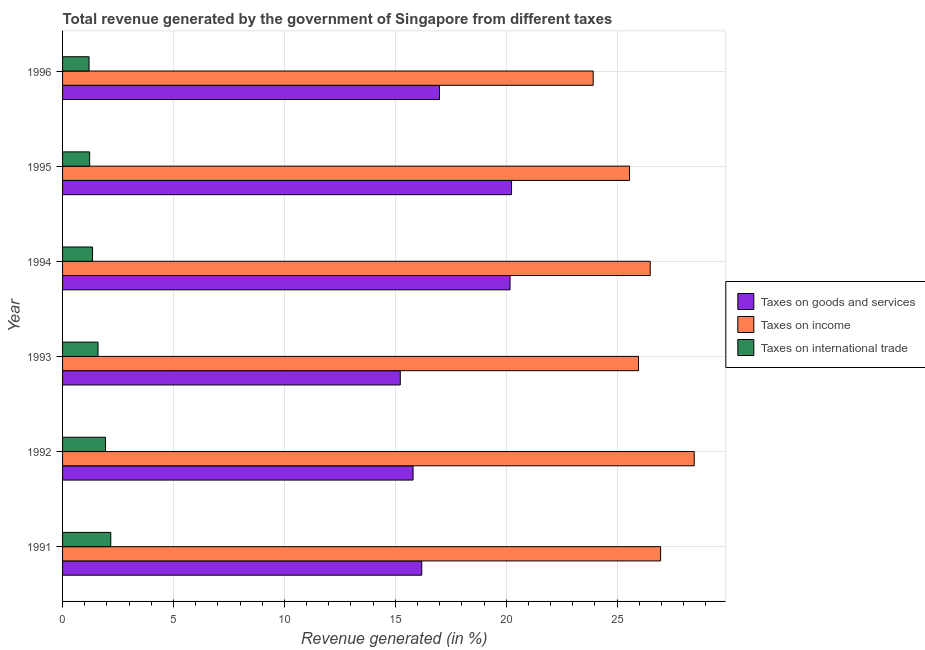How many groups of bars are there?
Offer a very short reply. 6. Are the number of bars per tick equal to the number of legend labels?
Offer a very short reply. Yes. Are the number of bars on each tick of the Y-axis equal?
Provide a succinct answer. Yes. How many bars are there on the 3rd tick from the bottom?
Your response must be concise. 3. What is the percentage of revenue generated by tax on international trade in 1996?
Give a very brief answer. 1.19. Across all years, what is the maximum percentage of revenue generated by taxes on income?
Give a very brief answer. 28.47. Across all years, what is the minimum percentage of revenue generated by taxes on goods and services?
Make the answer very short. 15.22. In which year was the percentage of revenue generated by taxes on goods and services maximum?
Make the answer very short. 1995. What is the total percentage of revenue generated by tax on international trade in the graph?
Your answer should be compact. 9.47. What is the difference between the percentage of revenue generated by taxes on income in 1992 and that in 1996?
Ensure brevity in your answer.  4.55. What is the difference between the percentage of revenue generated by taxes on income in 1994 and the percentage of revenue generated by tax on international trade in 1993?
Your response must be concise. 24.89. What is the average percentage of revenue generated by taxes on income per year?
Provide a succinct answer. 26.23. In the year 1993, what is the difference between the percentage of revenue generated by taxes on income and percentage of revenue generated by taxes on goods and services?
Offer a very short reply. 10.74. In how many years, is the percentage of revenue generated by tax on international trade greater than 4 %?
Your answer should be very brief. 0. What is the ratio of the percentage of revenue generated by taxes on income in 1992 to that in 1994?
Ensure brevity in your answer.  1.07. What is the difference between the highest and the second highest percentage of revenue generated by taxes on income?
Offer a very short reply. 1.51. What is the difference between the highest and the lowest percentage of revenue generated by taxes on income?
Offer a terse response. 4.55. Is the sum of the percentage of revenue generated by tax on international trade in 1993 and 1996 greater than the maximum percentage of revenue generated by taxes on income across all years?
Ensure brevity in your answer.  No. What does the 2nd bar from the top in 1991 represents?
Provide a short and direct response. Taxes on income. What does the 3rd bar from the bottom in 1993 represents?
Provide a short and direct response. Taxes on international trade. Are all the bars in the graph horizontal?
Offer a terse response. Yes. Does the graph contain any zero values?
Your response must be concise. No. How are the legend labels stacked?
Offer a very short reply. Vertical. What is the title of the graph?
Your response must be concise. Total revenue generated by the government of Singapore from different taxes. Does "Liquid fuel" appear as one of the legend labels in the graph?
Provide a succinct answer. No. What is the label or title of the X-axis?
Keep it short and to the point. Revenue generated (in %). What is the label or title of the Y-axis?
Your answer should be very brief. Year. What is the Revenue generated (in %) in Taxes on goods and services in 1991?
Keep it short and to the point. 16.19. What is the Revenue generated (in %) of Taxes on income in 1991?
Offer a very short reply. 26.96. What is the Revenue generated (in %) of Taxes on international trade in 1991?
Your answer should be compact. 2.17. What is the Revenue generated (in %) in Taxes on goods and services in 1992?
Your answer should be very brief. 15.8. What is the Revenue generated (in %) of Taxes on income in 1992?
Offer a terse response. 28.47. What is the Revenue generated (in %) in Taxes on international trade in 1992?
Your answer should be very brief. 1.93. What is the Revenue generated (in %) in Taxes on goods and services in 1993?
Offer a very short reply. 15.22. What is the Revenue generated (in %) of Taxes on income in 1993?
Your answer should be very brief. 25.96. What is the Revenue generated (in %) of Taxes on international trade in 1993?
Provide a short and direct response. 1.6. What is the Revenue generated (in %) of Taxes on goods and services in 1994?
Provide a short and direct response. 20.17. What is the Revenue generated (in %) in Taxes on income in 1994?
Ensure brevity in your answer.  26.49. What is the Revenue generated (in %) of Taxes on international trade in 1994?
Your response must be concise. 1.35. What is the Revenue generated (in %) in Taxes on goods and services in 1995?
Your answer should be compact. 20.24. What is the Revenue generated (in %) in Taxes on income in 1995?
Provide a succinct answer. 25.56. What is the Revenue generated (in %) in Taxes on international trade in 1995?
Your response must be concise. 1.22. What is the Revenue generated (in %) in Taxes on goods and services in 1996?
Ensure brevity in your answer.  16.99. What is the Revenue generated (in %) in Taxes on income in 1996?
Keep it short and to the point. 23.92. What is the Revenue generated (in %) in Taxes on international trade in 1996?
Give a very brief answer. 1.19. Across all years, what is the maximum Revenue generated (in %) of Taxes on goods and services?
Offer a terse response. 20.24. Across all years, what is the maximum Revenue generated (in %) of Taxes on income?
Give a very brief answer. 28.47. Across all years, what is the maximum Revenue generated (in %) of Taxes on international trade?
Offer a terse response. 2.17. Across all years, what is the minimum Revenue generated (in %) in Taxes on goods and services?
Your response must be concise. 15.22. Across all years, what is the minimum Revenue generated (in %) of Taxes on income?
Make the answer very short. 23.92. Across all years, what is the minimum Revenue generated (in %) in Taxes on international trade?
Ensure brevity in your answer.  1.19. What is the total Revenue generated (in %) in Taxes on goods and services in the graph?
Give a very brief answer. 104.62. What is the total Revenue generated (in %) of Taxes on income in the graph?
Your answer should be compact. 157.36. What is the total Revenue generated (in %) of Taxes on international trade in the graph?
Keep it short and to the point. 9.47. What is the difference between the Revenue generated (in %) in Taxes on goods and services in 1991 and that in 1992?
Give a very brief answer. 0.39. What is the difference between the Revenue generated (in %) in Taxes on income in 1991 and that in 1992?
Offer a terse response. -1.51. What is the difference between the Revenue generated (in %) in Taxes on international trade in 1991 and that in 1992?
Offer a very short reply. 0.24. What is the difference between the Revenue generated (in %) in Taxes on goods and services in 1991 and that in 1993?
Ensure brevity in your answer.  0.97. What is the difference between the Revenue generated (in %) of Taxes on income in 1991 and that in 1993?
Provide a short and direct response. 1. What is the difference between the Revenue generated (in %) of Taxes on international trade in 1991 and that in 1993?
Your answer should be very brief. 0.58. What is the difference between the Revenue generated (in %) of Taxes on goods and services in 1991 and that in 1994?
Your answer should be very brief. -3.98. What is the difference between the Revenue generated (in %) in Taxes on income in 1991 and that in 1994?
Offer a very short reply. 0.47. What is the difference between the Revenue generated (in %) of Taxes on international trade in 1991 and that in 1994?
Offer a terse response. 0.82. What is the difference between the Revenue generated (in %) in Taxes on goods and services in 1991 and that in 1995?
Make the answer very short. -4.05. What is the difference between the Revenue generated (in %) of Taxes on income in 1991 and that in 1995?
Give a very brief answer. 1.4. What is the difference between the Revenue generated (in %) in Taxes on international trade in 1991 and that in 1995?
Provide a short and direct response. 0.95. What is the difference between the Revenue generated (in %) of Taxes on goods and services in 1991 and that in 1996?
Your answer should be very brief. -0.8. What is the difference between the Revenue generated (in %) in Taxes on income in 1991 and that in 1996?
Your answer should be compact. 3.04. What is the difference between the Revenue generated (in %) in Taxes on international trade in 1991 and that in 1996?
Your answer should be compact. 0.98. What is the difference between the Revenue generated (in %) in Taxes on goods and services in 1992 and that in 1993?
Ensure brevity in your answer.  0.58. What is the difference between the Revenue generated (in %) of Taxes on income in 1992 and that in 1993?
Give a very brief answer. 2.51. What is the difference between the Revenue generated (in %) of Taxes on international trade in 1992 and that in 1993?
Provide a short and direct response. 0.34. What is the difference between the Revenue generated (in %) of Taxes on goods and services in 1992 and that in 1994?
Offer a very short reply. -4.37. What is the difference between the Revenue generated (in %) in Taxes on income in 1992 and that in 1994?
Offer a very short reply. 1.98. What is the difference between the Revenue generated (in %) in Taxes on international trade in 1992 and that in 1994?
Your answer should be compact. 0.58. What is the difference between the Revenue generated (in %) in Taxes on goods and services in 1992 and that in 1995?
Offer a very short reply. -4.44. What is the difference between the Revenue generated (in %) of Taxes on income in 1992 and that in 1995?
Your answer should be very brief. 2.92. What is the difference between the Revenue generated (in %) in Taxes on international trade in 1992 and that in 1995?
Provide a succinct answer. 0.71. What is the difference between the Revenue generated (in %) in Taxes on goods and services in 1992 and that in 1996?
Give a very brief answer. -1.19. What is the difference between the Revenue generated (in %) in Taxes on income in 1992 and that in 1996?
Your answer should be very brief. 4.55. What is the difference between the Revenue generated (in %) of Taxes on international trade in 1992 and that in 1996?
Your response must be concise. 0.74. What is the difference between the Revenue generated (in %) in Taxes on goods and services in 1993 and that in 1994?
Your response must be concise. -4.95. What is the difference between the Revenue generated (in %) of Taxes on income in 1993 and that in 1994?
Provide a succinct answer. -0.53. What is the difference between the Revenue generated (in %) in Taxes on international trade in 1993 and that in 1994?
Offer a very short reply. 0.25. What is the difference between the Revenue generated (in %) of Taxes on goods and services in 1993 and that in 1995?
Make the answer very short. -5.02. What is the difference between the Revenue generated (in %) in Taxes on income in 1993 and that in 1995?
Your answer should be compact. 0.4. What is the difference between the Revenue generated (in %) in Taxes on international trade in 1993 and that in 1995?
Keep it short and to the point. 0.38. What is the difference between the Revenue generated (in %) in Taxes on goods and services in 1993 and that in 1996?
Your answer should be compact. -1.77. What is the difference between the Revenue generated (in %) in Taxes on income in 1993 and that in 1996?
Provide a short and direct response. 2.04. What is the difference between the Revenue generated (in %) in Taxes on international trade in 1993 and that in 1996?
Offer a terse response. 0.4. What is the difference between the Revenue generated (in %) in Taxes on goods and services in 1994 and that in 1995?
Give a very brief answer. -0.07. What is the difference between the Revenue generated (in %) of Taxes on income in 1994 and that in 1995?
Ensure brevity in your answer.  0.93. What is the difference between the Revenue generated (in %) in Taxes on international trade in 1994 and that in 1995?
Your response must be concise. 0.13. What is the difference between the Revenue generated (in %) in Taxes on goods and services in 1994 and that in 1996?
Ensure brevity in your answer.  3.18. What is the difference between the Revenue generated (in %) of Taxes on income in 1994 and that in 1996?
Keep it short and to the point. 2.57. What is the difference between the Revenue generated (in %) in Taxes on international trade in 1994 and that in 1996?
Provide a short and direct response. 0.16. What is the difference between the Revenue generated (in %) in Taxes on goods and services in 1995 and that in 1996?
Provide a short and direct response. 3.25. What is the difference between the Revenue generated (in %) of Taxes on income in 1995 and that in 1996?
Keep it short and to the point. 1.64. What is the difference between the Revenue generated (in %) in Taxes on international trade in 1995 and that in 1996?
Your response must be concise. 0.03. What is the difference between the Revenue generated (in %) in Taxes on goods and services in 1991 and the Revenue generated (in %) in Taxes on income in 1992?
Offer a terse response. -12.28. What is the difference between the Revenue generated (in %) of Taxes on goods and services in 1991 and the Revenue generated (in %) of Taxes on international trade in 1992?
Keep it short and to the point. 14.26. What is the difference between the Revenue generated (in %) of Taxes on income in 1991 and the Revenue generated (in %) of Taxes on international trade in 1992?
Give a very brief answer. 25.02. What is the difference between the Revenue generated (in %) in Taxes on goods and services in 1991 and the Revenue generated (in %) in Taxes on income in 1993?
Make the answer very short. -9.77. What is the difference between the Revenue generated (in %) in Taxes on goods and services in 1991 and the Revenue generated (in %) in Taxes on international trade in 1993?
Give a very brief answer. 14.59. What is the difference between the Revenue generated (in %) in Taxes on income in 1991 and the Revenue generated (in %) in Taxes on international trade in 1993?
Offer a terse response. 25.36. What is the difference between the Revenue generated (in %) of Taxes on goods and services in 1991 and the Revenue generated (in %) of Taxes on income in 1994?
Make the answer very short. -10.3. What is the difference between the Revenue generated (in %) in Taxes on goods and services in 1991 and the Revenue generated (in %) in Taxes on international trade in 1994?
Your answer should be compact. 14.84. What is the difference between the Revenue generated (in %) of Taxes on income in 1991 and the Revenue generated (in %) of Taxes on international trade in 1994?
Provide a succinct answer. 25.61. What is the difference between the Revenue generated (in %) of Taxes on goods and services in 1991 and the Revenue generated (in %) of Taxes on income in 1995?
Ensure brevity in your answer.  -9.37. What is the difference between the Revenue generated (in %) in Taxes on goods and services in 1991 and the Revenue generated (in %) in Taxes on international trade in 1995?
Your answer should be very brief. 14.97. What is the difference between the Revenue generated (in %) of Taxes on income in 1991 and the Revenue generated (in %) of Taxes on international trade in 1995?
Your response must be concise. 25.74. What is the difference between the Revenue generated (in %) in Taxes on goods and services in 1991 and the Revenue generated (in %) in Taxes on income in 1996?
Offer a very short reply. -7.73. What is the difference between the Revenue generated (in %) of Taxes on goods and services in 1991 and the Revenue generated (in %) of Taxes on international trade in 1996?
Your answer should be compact. 15. What is the difference between the Revenue generated (in %) in Taxes on income in 1991 and the Revenue generated (in %) in Taxes on international trade in 1996?
Provide a short and direct response. 25.77. What is the difference between the Revenue generated (in %) of Taxes on goods and services in 1992 and the Revenue generated (in %) of Taxes on income in 1993?
Offer a terse response. -10.16. What is the difference between the Revenue generated (in %) in Taxes on goods and services in 1992 and the Revenue generated (in %) in Taxes on international trade in 1993?
Your answer should be very brief. 14.2. What is the difference between the Revenue generated (in %) in Taxes on income in 1992 and the Revenue generated (in %) in Taxes on international trade in 1993?
Keep it short and to the point. 26.88. What is the difference between the Revenue generated (in %) in Taxes on goods and services in 1992 and the Revenue generated (in %) in Taxes on income in 1994?
Your answer should be very brief. -10.69. What is the difference between the Revenue generated (in %) of Taxes on goods and services in 1992 and the Revenue generated (in %) of Taxes on international trade in 1994?
Your answer should be very brief. 14.45. What is the difference between the Revenue generated (in %) of Taxes on income in 1992 and the Revenue generated (in %) of Taxes on international trade in 1994?
Provide a succinct answer. 27.12. What is the difference between the Revenue generated (in %) in Taxes on goods and services in 1992 and the Revenue generated (in %) in Taxes on income in 1995?
Offer a very short reply. -9.76. What is the difference between the Revenue generated (in %) in Taxes on goods and services in 1992 and the Revenue generated (in %) in Taxes on international trade in 1995?
Keep it short and to the point. 14.58. What is the difference between the Revenue generated (in %) of Taxes on income in 1992 and the Revenue generated (in %) of Taxes on international trade in 1995?
Your answer should be compact. 27.25. What is the difference between the Revenue generated (in %) of Taxes on goods and services in 1992 and the Revenue generated (in %) of Taxes on income in 1996?
Your answer should be compact. -8.12. What is the difference between the Revenue generated (in %) of Taxes on goods and services in 1992 and the Revenue generated (in %) of Taxes on international trade in 1996?
Provide a short and direct response. 14.61. What is the difference between the Revenue generated (in %) of Taxes on income in 1992 and the Revenue generated (in %) of Taxes on international trade in 1996?
Make the answer very short. 27.28. What is the difference between the Revenue generated (in %) in Taxes on goods and services in 1993 and the Revenue generated (in %) in Taxes on income in 1994?
Give a very brief answer. -11.27. What is the difference between the Revenue generated (in %) in Taxes on goods and services in 1993 and the Revenue generated (in %) in Taxes on international trade in 1994?
Offer a very short reply. 13.87. What is the difference between the Revenue generated (in %) in Taxes on income in 1993 and the Revenue generated (in %) in Taxes on international trade in 1994?
Your answer should be very brief. 24.61. What is the difference between the Revenue generated (in %) of Taxes on goods and services in 1993 and the Revenue generated (in %) of Taxes on income in 1995?
Ensure brevity in your answer.  -10.33. What is the difference between the Revenue generated (in %) in Taxes on goods and services in 1993 and the Revenue generated (in %) in Taxes on international trade in 1995?
Give a very brief answer. 14. What is the difference between the Revenue generated (in %) of Taxes on income in 1993 and the Revenue generated (in %) of Taxes on international trade in 1995?
Keep it short and to the point. 24.74. What is the difference between the Revenue generated (in %) of Taxes on goods and services in 1993 and the Revenue generated (in %) of Taxes on income in 1996?
Your answer should be compact. -8.7. What is the difference between the Revenue generated (in %) in Taxes on goods and services in 1993 and the Revenue generated (in %) in Taxes on international trade in 1996?
Make the answer very short. 14.03. What is the difference between the Revenue generated (in %) in Taxes on income in 1993 and the Revenue generated (in %) in Taxes on international trade in 1996?
Offer a very short reply. 24.77. What is the difference between the Revenue generated (in %) in Taxes on goods and services in 1994 and the Revenue generated (in %) in Taxes on income in 1995?
Offer a very short reply. -5.39. What is the difference between the Revenue generated (in %) in Taxes on goods and services in 1994 and the Revenue generated (in %) in Taxes on international trade in 1995?
Ensure brevity in your answer.  18.95. What is the difference between the Revenue generated (in %) in Taxes on income in 1994 and the Revenue generated (in %) in Taxes on international trade in 1995?
Ensure brevity in your answer.  25.27. What is the difference between the Revenue generated (in %) in Taxes on goods and services in 1994 and the Revenue generated (in %) in Taxes on income in 1996?
Ensure brevity in your answer.  -3.75. What is the difference between the Revenue generated (in %) in Taxes on goods and services in 1994 and the Revenue generated (in %) in Taxes on international trade in 1996?
Ensure brevity in your answer.  18.98. What is the difference between the Revenue generated (in %) in Taxes on income in 1994 and the Revenue generated (in %) in Taxes on international trade in 1996?
Your answer should be compact. 25.3. What is the difference between the Revenue generated (in %) of Taxes on goods and services in 1995 and the Revenue generated (in %) of Taxes on income in 1996?
Your response must be concise. -3.68. What is the difference between the Revenue generated (in %) of Taxes on goods and services in 1995 and the Revenue generated (in %) of Taxes on international trade in 1996?
Offer a terse response. 19.05. What is the difference between the Revenue generated (in %) in Taxes on income in 1995 and the Revenue generated (in %) in Taxes on international trade in 1996?
Your answer should be compact. 24.36. What is the average Revenue generated (in %) of Taxes on goods and services per year?
Keep it short and to the point. 17.44. What is the average Revenue generated (in %) of Taxes on income per year?
Keep it short and to the point. 26.23. What is the average Revenue generated (in %) of Taxes on international trade per year?
Provide a succinct answer. 1.58. In the year 1991, what is the difference between the Revenue generated (in %) of Taxes on goods and services and Revenue generated (in %) of Taxes on income?
Ensure brevity in your answer.  -10.77. In the year 1991, what is the difference between the Revenue generated (in %) in Taxes on goods and services and Revenue generated (in %) in Taxes on international trade?
Make the answer very short. 14.02. In the year 1991, what is the difference between the Revenue generated (in %) in Taxes on income and Revenue generated (in %) in Taxes on international trade?
Keep it short and to the point. 24.79. In the year 1992, what is the difference between the Revenue generated (in %) in Taxes on goods and services and Revenue generated (in %) in Taxes on income?
Ensure brevity in your answer.  -12.67. In the year 1992, what is the difference between the Revenue generated (in %) of Taxes on goods and services and Revenue generated (in %) of Taxes on international trade?
Provide a short and direct response. 13.87. In the year 1992, what is the difference between the Revenue generated (in %) in Taxes on income and Revenue generated (in %) in Taxes on international trade?
Offer a terse response. 26.54. In the year 1993, what is the difference between the Revenue generated (in %) of Taxes on goods and services and Revenue generated (in %) of Taxes on income?
Offer a very short reply. -10.74. In the year 1993, what is the difference between the Revenue generated (in %) of Taxes on goods and services and Revenue generated (in %) of Taxes on international trade?
Give a very brief answer. 13.63. In the year 1993, what is the difference between the Revenue generated (in %) of Taxes on income and Revenue generated (in %) of Taxes on international trade?
Your answer should be compact. 24.36. In the year 1994, what is the difference between the Revenue generated (in %) of Taxes on goods and services and Revenue generated (in %) of Taxes on income?
Keep it short and to the point. -6.32. In the year 1994, what is the difference between the Revenue generated (in %) in Taxes on goods and services and Revenue generated (in %) in Taxes on international trade?
Your answer should be compact. 18.82. In the year 1994, what is the difference between the Revenue generated (in %) of Taxes on income and Revenue generated (in %) of Taxes on international trade?
Ensure brevity in your answer.  25.14. In the year 1995, what is the difference between the Revenue generated (in %) in Taxes on goods and services and Revenue generated (in %) in Taxes on income?
Provide a succinct answer. -5.32. In the year 1995, what is the difference between the Revenue generated (in %) in Taxes on goods and services and Revenue generated (in %) in Taxes on international trade?
Give a very brief answer. 19.02. In the year 1995, what is the difference between the Revenue generated (in %) in Taxes on income and Revenue generated (in %) in Taxes on international trade?
Your answer should be compact. 24.34. In the year 1996, what is the difference between the Revenue generated (in %) of Taxes on goods and services and Revenue generated (in %) of Taxes on income?
Make the answer very short. -6.93. In the year 1996, what is the difference between the Revenue generated (in %) in Taxes on goods and services and Revenue generated (in %) in Taxes on international trade?
Your response must be concise. 15.8. In the year 1996, what is the difference between the Revenue generated (in %) of Taxes on income and Revenue generated (in %) of Taxes on international trade?
Your answer should be compact. 22.73. What is the ratio of the Revenue generated (in %) in Taxes on goods and services in 1991 to that in 1992?
Offer a terse response. 1.02. What is the ratio of the Revenue generated (in %) in Taxes on income in 1991 to that in 1992?
Make the answer very short. 0.95. What is the ratio of the Revenue generated (in %) of Taxes on international trade in 1991 to that in 1992?
Your response must be concise. 1.12. What is the ratio of the Revenue generated (in %) in Taxes on goods and services in 1991 to that in 1993?
Provide a short and direct response. 1.06. What is the ratio of the Revenue generated (in %) of Taxes on income in 1991 to that in 1993?
Provide a short and direct response. 1.04. What is the ratio of the Revenue generated (in %) of Taxes on international trade in 1991 to that in 1993?
Offer a terse response. 1.36. What is the ratio of the Revenue generated (in %) in Taxes on goods and services in 1991 to that in 1994?
Your answer should be compact. 0.8. What is the ratio of the Revenue generated (in %) of Taxes on income in 1991 to that in 1994?
Your answer should be compact. 1.02. What is the ratio of the Revenue generated (in %) of Taxes on international trade in 1991 to that in 1994?
Provide a succinct answer. 1.61. What is the ratio of the Revenue generated (in %) of Taxes on goods and services in 1991 to that in 1995?
Your answer should be very brief. 0.8. What is the ratio of the Revenue generated (in %) of Taxes on income in 1991 to that in 1995?
Provide a succinct answer. 1.05. What is the ratio of the Revenue generated (in %) in Taxes on international trade in 1991 to that in 1995?
Your response must be concise. 1.78. What is the ratio of the Revenue generated (in %) of Taxes on goods and services in 1991 to that in 1996?
Give a very brief answer. 0.95. What is the ratio of the Revenue generated (in %) of Taxes on income in 1991 to that in 1996?
Your response must be concise. 1.13. What is the ratio of the Revenue generated (in %) in Taxes on international trade in 1991 to that in 1996?
Keep it short and to the point. 1.82. What is the ratio of the Revenue generated (in %) in Taxes on goods and services in 1992 to that in 1993?
Your answer should be very brief. 1.04. What is the ratio of the Revenue generated (in %) in Taxes on income in 1992 to that in 1993?
Provide a succinct answer. 1.1. What is the ratio of the Revenue generated (in %) in Taxes on international trade in 1992 to that in 1993?
Provide a succinct answer. 1.21. What is the ratio of the Revenue generated (in %) in Taxes on goods and services in 1992 to that in 1994?
Offer a terse response. 0.78. What is the ratio of the Revenue generated (in %) of Taxes on income in 1992 to that in 1994?
Ensure brevity in your answer.  1.07. What is the ratio of the Revenue generated (in %) in Taxes on international trade in 1992 to that in 1994?
Keep it short and to the point. 1.43. What is the ratio of the Revenue generated (in %) in Taxes on goods and services in 1992 to that in 1995?
Your answer should be very brief. 0.78. What is the ratio of the Revenue generated (in %) in Taxes on income in 1992 to that in 1995?
Offer a terse response. 1.11. What is the ratio of the Revenue generated (in %) of Taxes on international trade in 1992 to that in 1995?
Offer a terse response. 1.58. What is the ratio of the Revenue generated (in %) of Taxes on goods and services in 1992 to that in 1996?
Your answer should be compact. 0.93. What is the ratio of the Revenue generated (in %) of Taxes on income in 1992 to that in 1996?
Your answer should be very brief. 1.19. What is the ratio of the Revenue generated (in %) in Taxes on international trade in 1992 to that in 1996?
Provide a short and direct response. 1.62. What is the ratio of the Revenue generated (in %) of Taxes on goods and services in 1993 to that in 1994?
Keep it short and to the point. 0.75. What is the ratio of the Revenue generated (in %) of Taxes on income in 1993 to that in 1994?
Provide a succinct answer. 0.98. What is the ratio of the Revenue generated (in %) in Taxes on international trade in 1993 to that in 1994?
Offer a very short reply. 1.18. What is the ratio of the Revenue generated (in %) of Taxes on goods and services in 1993 to that in 1995?
Give a very brief answer. 0.75. What is the ratio of the Revenue generated (in %) in Taxes on income in 1993 to that in 1995?
Keep it short and to the point. 1.02. What is the ratio of the Revenue generated (in %) in Taxes on international trade in 1993 to that in 1995?
Your response must be concise. 1.31. What is the ratio of the Revenue generated (in %) in Taxes on goods and services in 1993 to that in 1996?
Your response must be concise. 0.9. What is the ratio of the Revenue generated (in %) in Taxes on income in 1993 to that in 1996?
Provide a short and direct response. 1.09. What is the ratio of the Revenue generated (in %) of Taxes on international trade in 1993 to that in 1996?
Offer a very short reply. 1.34. What is the ratio of the Revenue generated (in %) in Taxes on goods and services in 1994 to that in 1995?
Keep it short and to the point. 1. What is the ratio of the Revenue generated (in %) of Taxes on income in 1994 to that in 1995?
Give a very brief answer. 1.04. What is the ratio of the Revenue generated (in %) in Taxes on international trade in 1994 to that in 1995?
Provide a succinct answer. 1.11. What is the ratio of the Revenue generated (in %) in Taxes on goods and services in 1994 to that in 1996?
Ensure brevity in your answer.  1.19. What is the ratio of the Revenue generated (in %) of Taxes on income in 1994 to that in 1996?
Provide a short and direct response. 1.11. What is the ratio of the Revenue generated (in %) in Taxes on international trade in 1994 to that in 1996?
Your answer should be compact. 1.13. What is the ratio of the Revenue generated (in %) of Taxes on goods and services in 1995 to that in 1996?
Keep it short and to the point. 1.19. What is the ratio of the Revenue generated (in %) of Taxes on income in 1995 to that in 1996?
Provide a succinct answer. 1.07. What is the ratio of the Revenue generated (in %) of Taxes on international trade in 1995 to that in 1996?
Make the answer very short. 1.02. What is the difference between the highest and the second highest Revenue generated (in %) in Taxes on goods and services?
Keep it short and to the point. 0.07. What is the difference between the highest and the second highest Revenue generated (in %) in Taxes on income?
Keep it short and to the point. 1.51. What is the difference between the highest and the second highest Revenue generated (in %) in Taxes on international trade?
Offer a terse response. 0.24. What is the difference between the highest and the lowest Revenue generated (in %) of Taxes on goods and services?
Your answer should be compact. 5.02. What is the difference between the highest and the lowest Revenue generated (in %) of Taxes on income?
Keep it short and to the point. 4.55. What is the difference between the highest and the lowest Revenue generated (in %) in Taxes on international trade?
Provide a short and direct response. 0.98. 